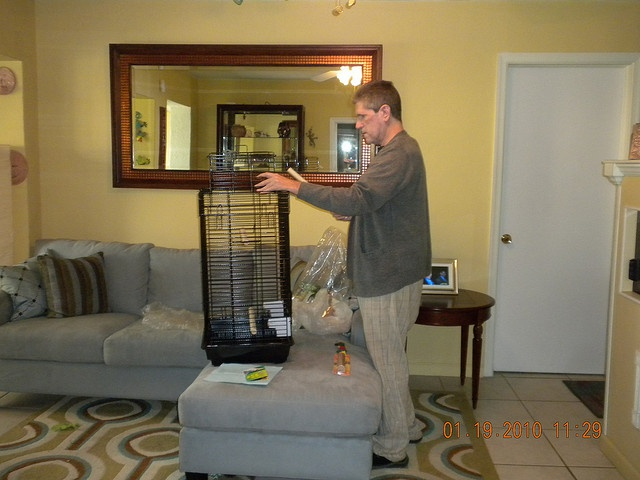Describe the objects in this image and their specific colors. I can see couch in olive, gray, and black tones, people in olive, gray, and black tones, and couch in olive, gray, and darkgray tones in this image. 